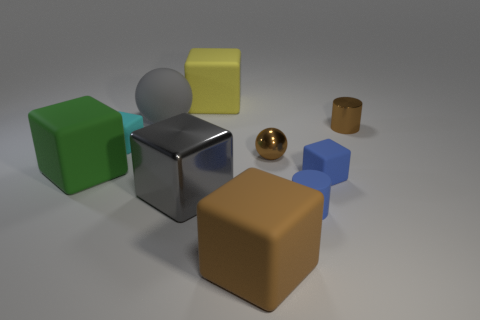Subtract all large brown cubes. How many cubes are left? 5 Subtract all green blocks. How many blocks are left? 5 Subtract all blue cylinders. Subtract all cyan cubes. How many cylinders are left? 1 Subtract all cubes. How many objects are left? 4 Subtract all brown objects. Subtract all blue rubber cubes. How many objects are left? 6 Add 2 tiny blue objects. How many tiny blue objects are left? 4 Add 8 brown matte balls. How many brown matte balls exist? 8 Subtract 0 blue spheres. How many objects are left? 10 